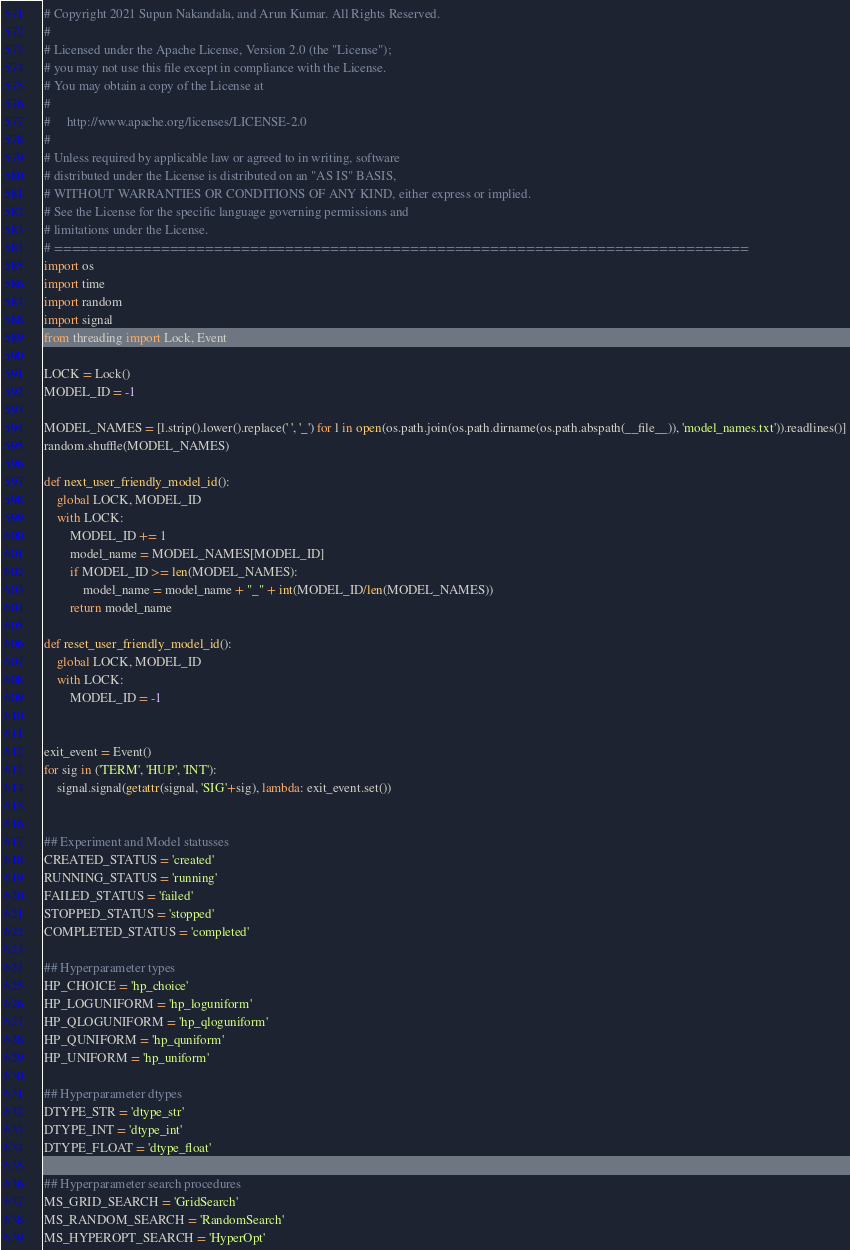<code> <loc_0><loc_0><loc_500><loc_500><_Python_># Copyright 2021 Supun Nakandala, and Arun Kumar. All Rights Reserved.
#
# Licensed under the Apache License, Version 2.0 (the "License");
# you may not use this file except in compliance with the License.
# You may obtain a copy of the License at
#
#     http://www.apache.org/licenses/LICENSE-2.0
#
# Unless required by applicable law or agreed to in writing, software
# distributed under the License is distributed on an "AS IS" BASIS,
# WITHOUT WARRANTIES OR CONDITIONS OF ANY KIND, either express or implied.
# See the License for the specific language governing permissions and
# limitations under the License.
# ==============================================================================
import os
import time
import random
import signal
from threading import Lock, Event

LOCK = Lock()
MODEL_ID = -1

MODEL_NAMES = [l.strip().lower().replace(' ', '_') for l in open(os.path.join(os.path.dirname(os.path.abspath(__file__)), 'model_names.txt')).readlines()]
random.shuffle(MODEL_NAMES)

def next_user_friendly_model_id():
    global LOCK, MODEL_ID
    with LOCK:
        MODEL_ID += 1
        model_name = MODEL_NAMES[MODEL_ID]
        if MODEL_ID >= len(MODEL_NAMES):
            model_name = model_name + "_" + int(MODEL_ID/len(MODEL_NAMES))
        return model_name

def reset_user_friendly_model_id():
    global LOCK, MODEL_ID
    with LOCK:
        MODEL_ID = -1


exit_event = Event()    
for sig in ('TERM', 'HUP', 'INT'):
    signal.signal(getattr(signal, 'SIG'+sig), lambda: exit_event.set())


## Experiment and Model statusses
CREATED_STATUS = 'created'
RUNNING_STATUS = 'running'
FAILED_STATUS = 'failed'
STOPPED_STATUS = 'stopped'
COMPLETED_STATUS = 'completed'

## Hyperparameter types
HP_CHOICE = 'hp_choice'
HP_LOGUNIFORM = 'hp_loguniform'
HP_QLOGUNIFORM = 'hp_qloguniform'
HP_QUNIFORM = 'hp_quniform'
HP_UNIFORM = 'hp_uniform'

## Hyperparameter dtypes
DTYPE_STR = 'dtype_str'
DTYPE_INT = 'dtype_int'
DTYPE_FLOAT = 'dtype_float'

## Hyperparameter search procedures
MS_GRID_SEARCH = 'GridSearch'
MS_RANDOM_SEARCH = 'RandomSearch'
MS_HYPEROPT_SEARCH = 'HyperOpt'
</code> 